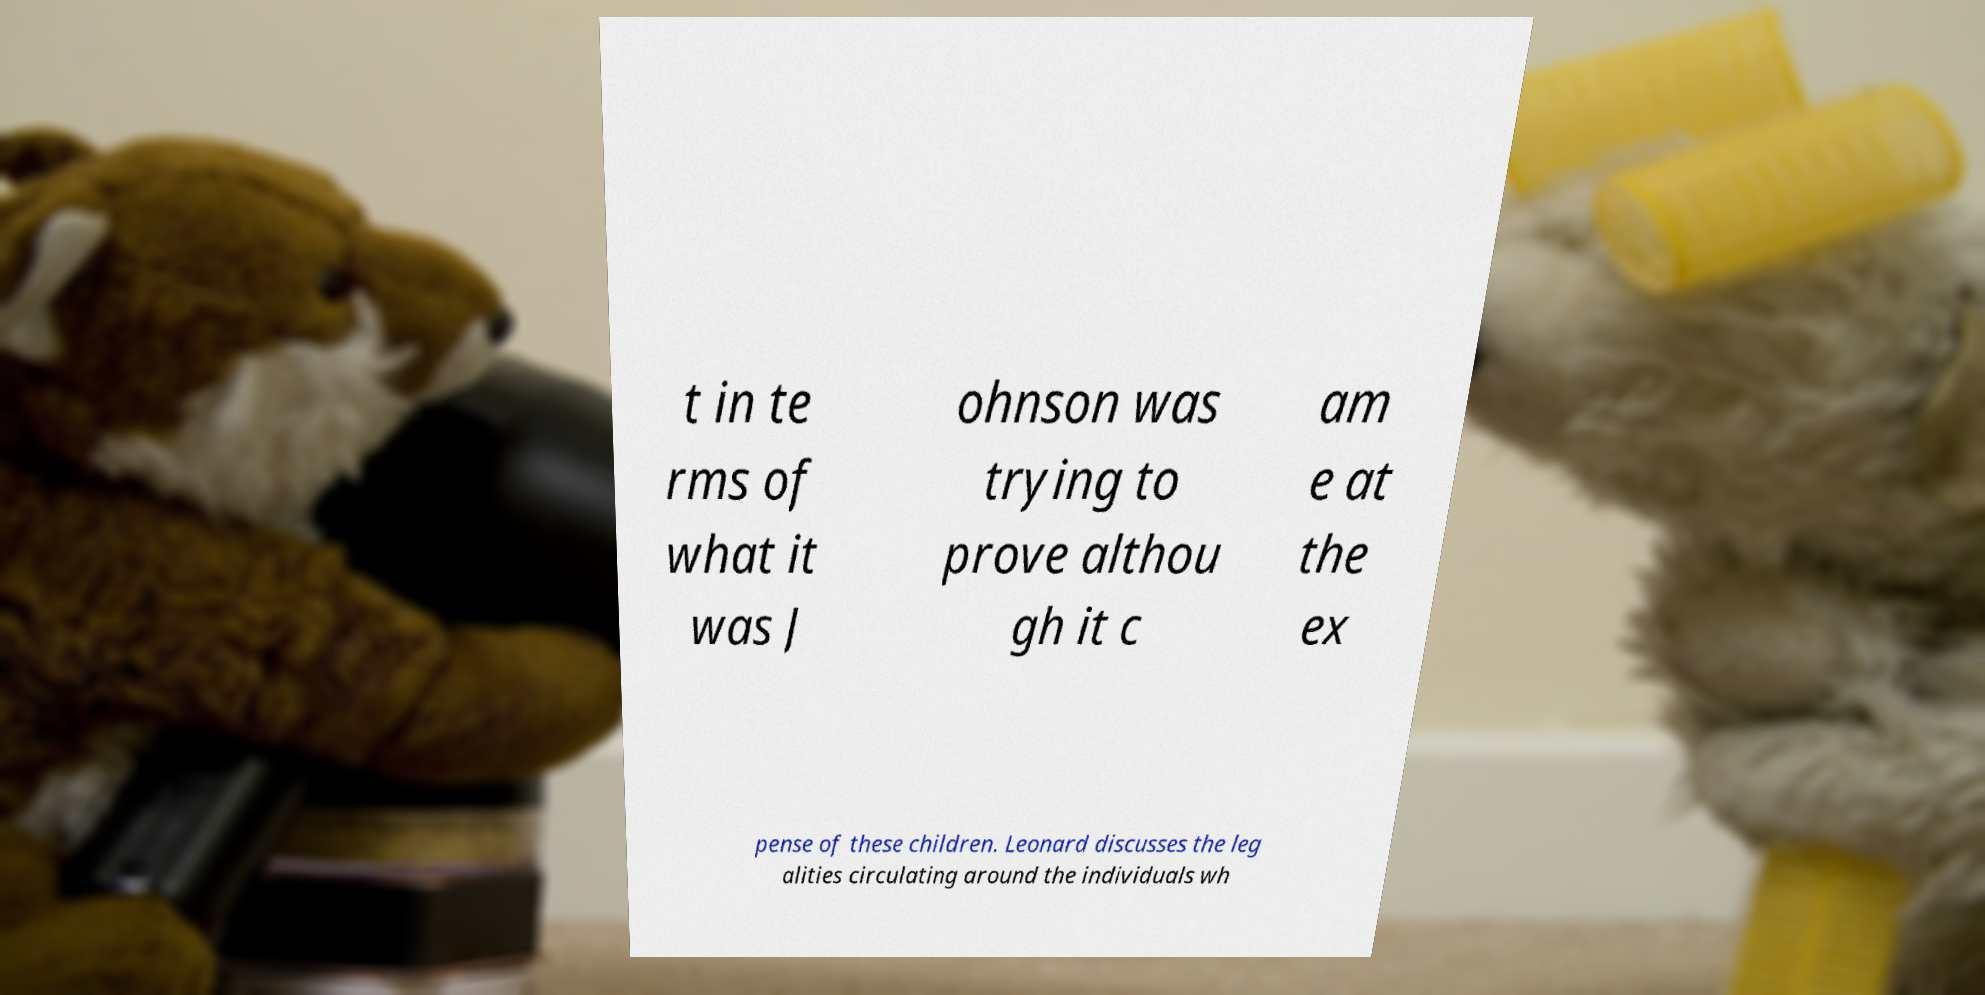Please read and relay the text visible in this image. What does it say? t in te rms of what it was J ohnson was trying to prove althou gh it c am e at the ex pense of these children. Leonard discusses the leg alities circulating around the individuals wh 